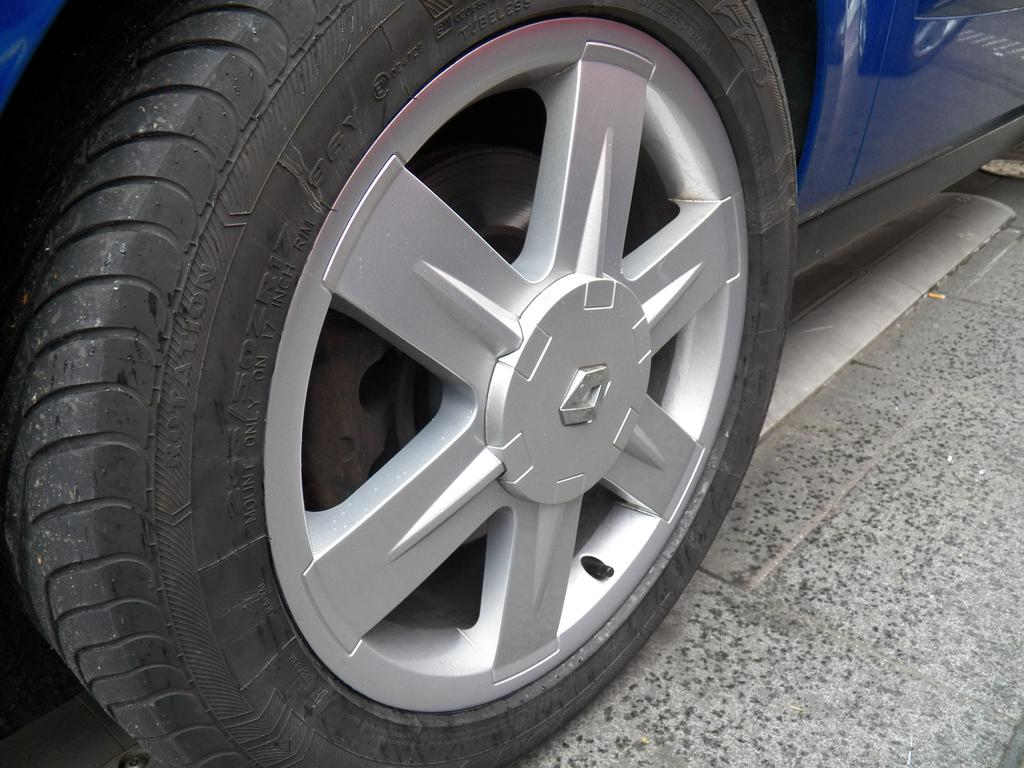What color is the vehicle in the image? The vehicle in the image is blue. Where is the vehicle located in the image? The vehicle is on the ground. What type of flag is being waved by the vehicle in the image? There is no flag present in the image, and the vehicle is not capable of waving anything. 